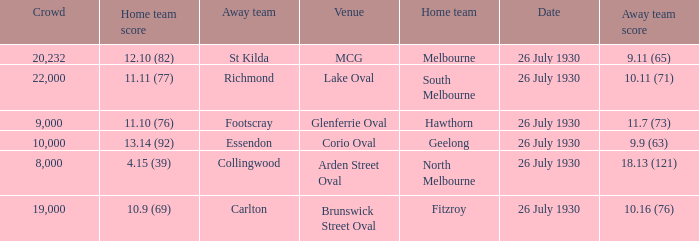When was Fitzroy the home team? 26 July 1930. 